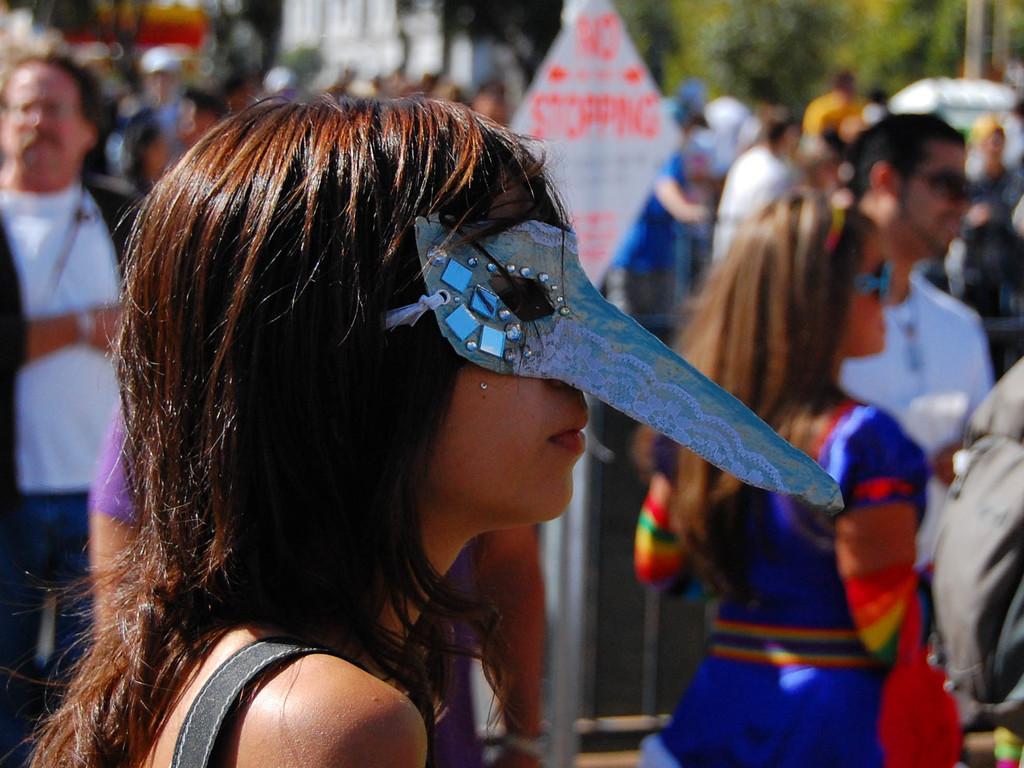How would you summarize this image in a sentence or two? In this image in the foreground there is one woman who is wearing a mask, and in the background there are a group of people who are standing and also there is one pole and board and some trees. 